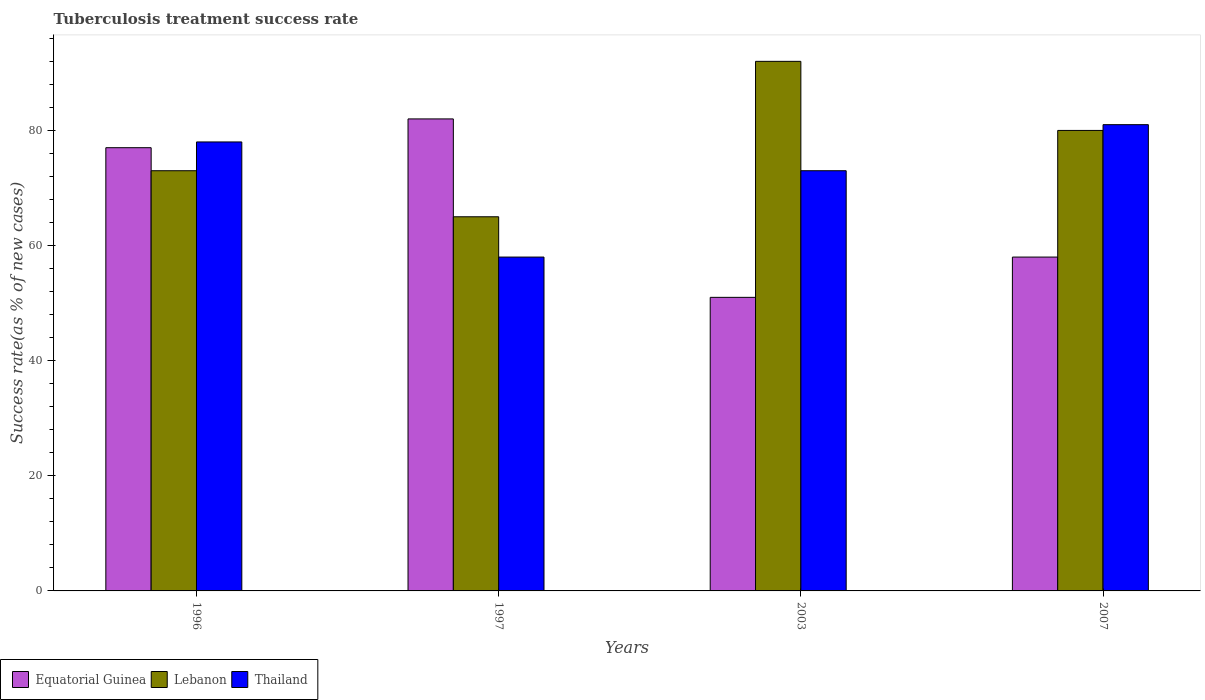Are the number of bars per tick equal to the number of legend labels?
Offer a very short reply. Yes. Are the number of bars on each tick of the X-axis equal?
Provide a succinct answer. Yes. In how many cases, is the number of bars for a given year not equal to the number of legend labels?
Make the answer very short. 0. What is the tuberculosis treatment success rate in Lebanon in 2003?
Offer a terse response. 92. Across all years, what is the maximum tuberculosis treatment success rate in Lebanon?
Your response must be concise. 92. Across all years, what is the minimum tuberculosis treatment success rate in Thailand?
Make the answer very short. 58. In which year was the tuberculosis treatment success rate in Lebanon maximum?
Offer a very short reply. 2003. What is the total tuberculosis treatment success rate in Lebanon in the graph?
Offer a terse response. 310. What is the difference between the tuberculosis treatment success rate in Thailand in 1996 and that in 2003?
Your response must be concise. 5. What is the difference between the tuberculosis treatment success rate in Equatorial Guinea in 1997 and the tuberculosis treatment success rate in Lebanon in 1996?
Offer a terse response. 9. What is the ratio of the tuberculosis treatment success rate in Lebanon in 1996 to that in 2003?
Provide a succinct answer. 0.79. What is the difference between the highest and the lowest tuberculosis treatment success rate in Thailand?
Offer a terse response. 23. Is the sum of the tuberculosis treatment success rate in Thailand in 2003 and 2007 greater than the maximum tuberculosis treatment success rate in Lebanon across all years?
Keep it short and to the point. Yes. What does the 3rd bar from the left in 1996 represents?
Keep it short and to the point. Thailand. What does the 2nd bar from the right in 1996 represents?
Provide a short and direct response. Lebanon. How many years are there in the graph?
Your answer should be very brief. 4. What is the difference between two consecutive major ticks on the Y-axis?
Offer a very short reply. 20. How are the legend labels stacked?
Ensure brevity in your answer.  Horizontal. What is the title of the graph?
Offer a very short reply. Tuberculosis treatment success rate. What is the label or title of the Y-axis?
Provide a short and direct response. Success rate(as % of new cases). What is the Success rate(as % of new cases) in Lebanon in 1996?
Your answer should be very brief. 73. What is the Success rate(as % of new cases) in Thailand in 1996?
Provide a short and direct response. 78. What is the Success rate(as % of new cases) in Thailand in 1997?
Your answer should be compact. 58. What is the Success rate(as % of new cases) of Lebanon in 2003?
Make the answer very short. 92. What is the Success rate(as % of new cases) of Equatorial Guinea in 2007?
Your answer should be very brief. 58. Across all years, what is the maximum Success rate(as % of new cases) in Lebanon?
Ensure brevity in your answer.  92. What is the total Success rate(as % of new cases) of Equatorial Guinea in the graph?
Offer a terse response. 268. What is the total Success rate(as % of new cases) in Lebanon in the graph?
Keep it short and to the point. 310. What is the total Success rate(as % of new cases) in Thailand in the graph?
Keep it short and to the point. 290. What is the difference between the Success rate(as % of new cases) of Equatorial Guinea in 1996 and that in 1997?
Your response must be concise. -5. What is the difference between the Success rate(as % of new cases) in Thailand in 1996 and that in 1997?
Your response must be concise. 20. What is the difference between the Success rate(as % of new cases) of Lebanon in 1996 and that in 2007?
Your response must be concise. -7. What is the difference between the Success rate(as % of new cases) in Lebanon in 1997 and that in 2007?
Give a very brief answer. -15. What is the difference between the Success rate(as % of new cases) of Equatorial Guinea in 2003 and that in 2007?
Your answer should be compact. -7. What is the difference between the Success rate(as % of new cases) of Equatorial Guinea in 1996 and the Success rate(as % of new cases) of Lebanon in 1997?
Your answer should be compact. 12. What is the difference between the Success rate(as % of new cases) of Equatorial Guinea in 1996 and the Success rate(as % of new cases) of Thailand in 1997?
Provide a short and direct response. 19. What is the difference between the Success rate(as % of new cases) of Equatorial Guinea in 1996 and the Success rate(as % of new cases) of Lebanon in 2003?
Keep it short and to the point. -15. What is the difference between the Success rate(as % of new cases) of Equatorial Guinea in 1996 and the Success rate(as % of new cases) of Thailand in 2003?
Make the answer very short. 4. What is the difference between the Success rate(as % of new cases) in Lebanon in 1996 and the Success rate(as % of new cases) in Thailand in 2003?
Provide a succinct answer. 0. What is the difference between the Success rate(as % of new cases) of Lebanon in 1996 and the Success rate(as % of new cases) of Thailand in 2007?
Your response must be concise. -8. What is the difference between the Success rate(as % of new cases) in Equatorial Guinea in 1997 and the Success rate(as % of new cases) in Lebanon in 2003?
Give a very brief answer. -10. What is the difference between the Success rate(as % of new cases) of Equatorial Guinea in 1997 and the Success rate(as % of new cases) of Thailand in 2003?
Give a very brief answer. 9. What is the difference between the Success rate(as % of new cases) in Equatorial Guinea in 1997 and the Success rate(as % of new cases) in Lebanon in 2007?
Your answer should be very brief. 2. What is the difference between the Success rate(as % of new cases) of Equatorial Guinea in 2003 and the Success rate(as % of new cases) of Lebanon in 2007?
Offer a very short reply. -29. What is the average Success rate(as % of new cases) in Equatorial Guinea per year?
Make the answer very short. 67. What is the average Success rate(as % of new cases) of Lebanon per year?
Offer a very short reply. 77.5. What is the average Success rate(as % of new cases) in Thailand per year?
Offer a very short reply. 72.5. In the year 1996, what is the difference between the Success rate(as % of new cases) in Equatorial Guinea and Success rate(as % of new cases) in Lebanon?
Offer a terse response. 4. In the year 1997, what is the difference between the Success rate(as % of new cases) of Lebanon and Success rate(as % of new cases) of Thailand?
Provide a succinct answer. 7. In the year 2003, what is the difference between the Success rate(as % of new cases) of Equatorial Guinea and Success rate(as % of new cases) of Lebanon?
Offer a terse response. -41. In the year 2003, what is the difference between the Success rate(as % of new cases) in Equatorial Guinea and Success rate(as % of new cases) in Thailand?
Your answer should be compact. -22. In the year 2007, what is the difference between the Success rate(as % of new cases) in Equatorial Guinea and Success rate(as % of new cases) in Thailand?
Ensure brevity in your answer.  -23. In the year 2007, what is the difference between the Success rate(as % of new cases) of Lebanon and Success rate(as % of new cases) of Thailand?
Offer a very short reply. -1. What is the ratio of the Success rate(as % of new cases) in Equatorial Guinea in 1996 to that in 1997?
Make the answer very short. 0.94. What is the ratio of the Success rate(as % of new cases) in Lebanon in 1996 to that in 1997?
Give a very brief answer. 1.12. What is the ratio of the Success rate(as % of new cases) of Thailand in 1996 to that in 1997?
Offer a very short reply. 1.34. What is the ratio of the Success rate(as % of new cases) in Equatorial Guinea in 1996 to that in 2003?
Provide a succinct answer. 1.51. What is the ratio of the Success rate(as % of new cases) in Lebanon in 1996 to that in 2003?
Your answer should be compact. 0.79. What is the ratio of the Success rate(as % of new cases) of Thailand in 1996 to that in 2003?
Give a very brief answer. 1.07. What is the ratio of the Success rate(as % of new cases) in Equatorial Guinea in 1996 to that in 2007?
Your response must be concise. 1.33. What is the ratio of the Success rate(as % of new cases) of Lebanon in 1996 to that in 2007?
Provide a succinct answer. 0.91. What is the ratio of the Success rate(as % of new cases) of Thailand in 1996 to that in 2007?
Your answer should be very brief. 0.96. What is the ratio of the Success rate(as % of new cases) of Equatorial Guinea in 1997 to that in 2003?
Provide a succinct answer. 1.61. What is the ratio of the Success rate(as % of new cases) of Lebanon in 1997 to that in 2003?
Offer a very short reply. 0.71. What is the ratio of the Success rate(as % of new cases) of Thailand in 1997 to that in 2003?
Provide a short and direct response. 0.79. What is the ratio of the Success rate(as % of new cases) in Equatorial Guinea in 1997 to that in 2007?
Provide a short and direct response. 1.41. What is the ratio of the Success rate(as % of new cases) of Lebanon in 1997 to that in 2007?
Offer a very short reply. 0.81. What is the ratio of the Success rate(as % of new cases) in Thailand in 1997 to that in 2007?
Your answer should be compact. 0.72. What is the ratio of the Success rate(as % of new cases) in Equatorial Guinea in 2003 to that in 2007?
Provide a succinct answer. 0.88. What is the ratio of the Success rate(as % of new cases) in Lebanon in 2003 to that in 2007?
Provide a short and direct response. 1.15. What is the ratio of the Success rate(as % of new cases) in Thailand in 2003 to that in 2007?
Provide a succinct answer. 0.9. What is the difference between the highest and the second highest Success rate(as % of new cases) of Thailand?
Offer a very short reply. 3. What is the difference between the highest and the lowest Success rate(as % of new cases) in Equatorial Guinea?
Give a very brief answer. 31. What is the difference between the highest and the lowest Success rate(as % of new cases) in Thailand?
Give a very brief answer. 23. 